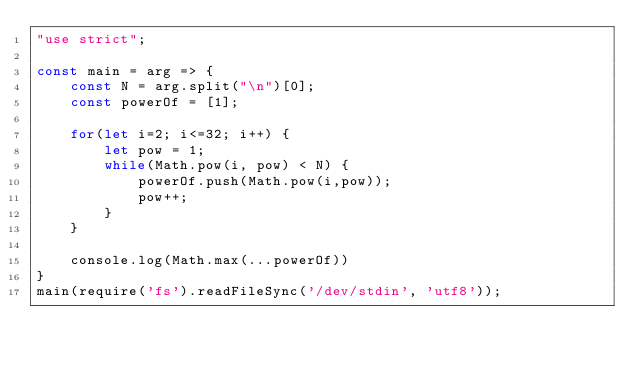<code> <loc_0><loc_0><loc_500><loc_500><_JavaScript_>"use strict";

const main = arg => {
    const N = arg.split("\n")[0];
    const powerOf = [1]; 
    
    for(let i=2; i<=32; i++) {
        let pow = 1;
        while(Math.pow(i, pow) < N) {
            powerOf.push(Math.pow(i,pow));
            pow++;
        }
    }
    
    console.log(Math.max(...powerOf))
}
main(require('fs').readFileSync('/dev/stdin', 'utf8'));</code> 